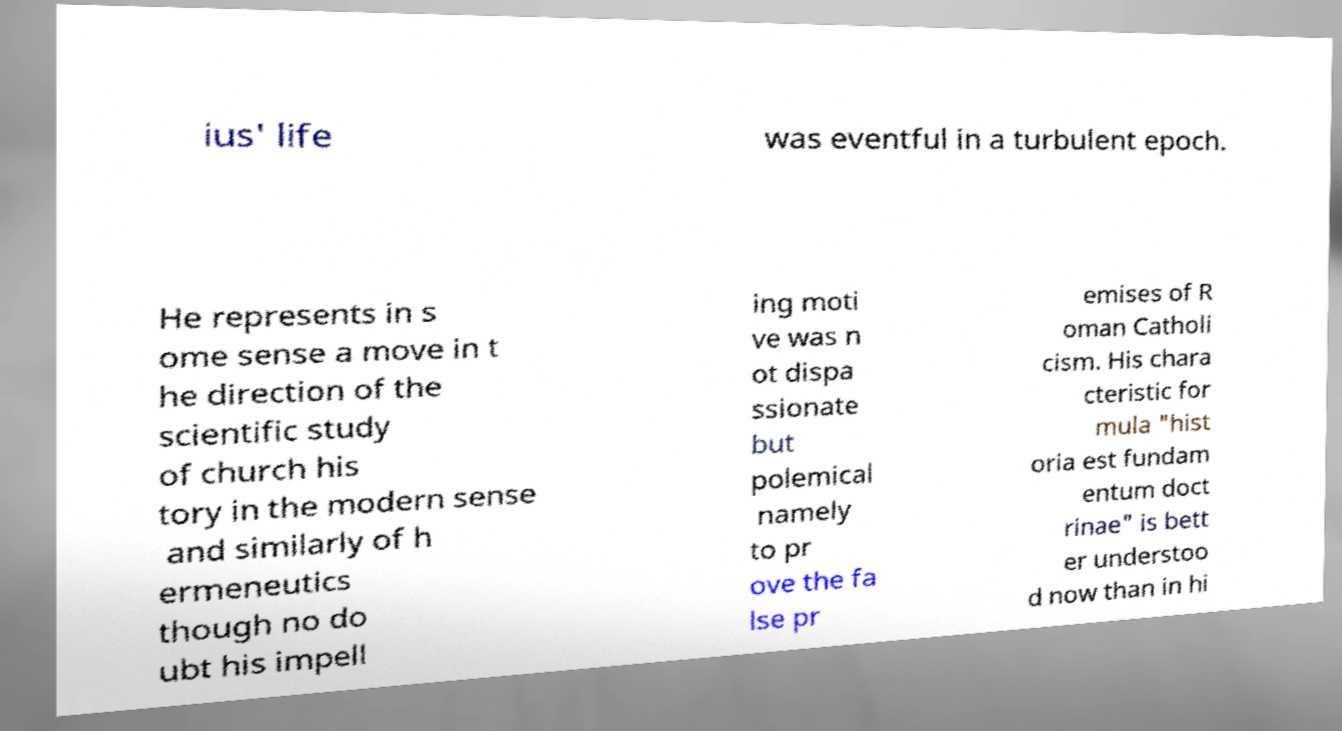Can you accurately transcribe the text from the provided image for me? ius' life was eventful in a turbulent epoch. He represents in s ome sense a move in t he direction of the scientific study of church his tory in the modern sense and similarly of h ermeneutics though no do ubt his impell ing moti ve was n ot dispa ssionate but polemical namely to pr ove the fa lse pr emises of R oman Catholi cism. His chara cteristic for mula "hist oria est fundam entum doct rinae" is bett er understoo d now than in hi 